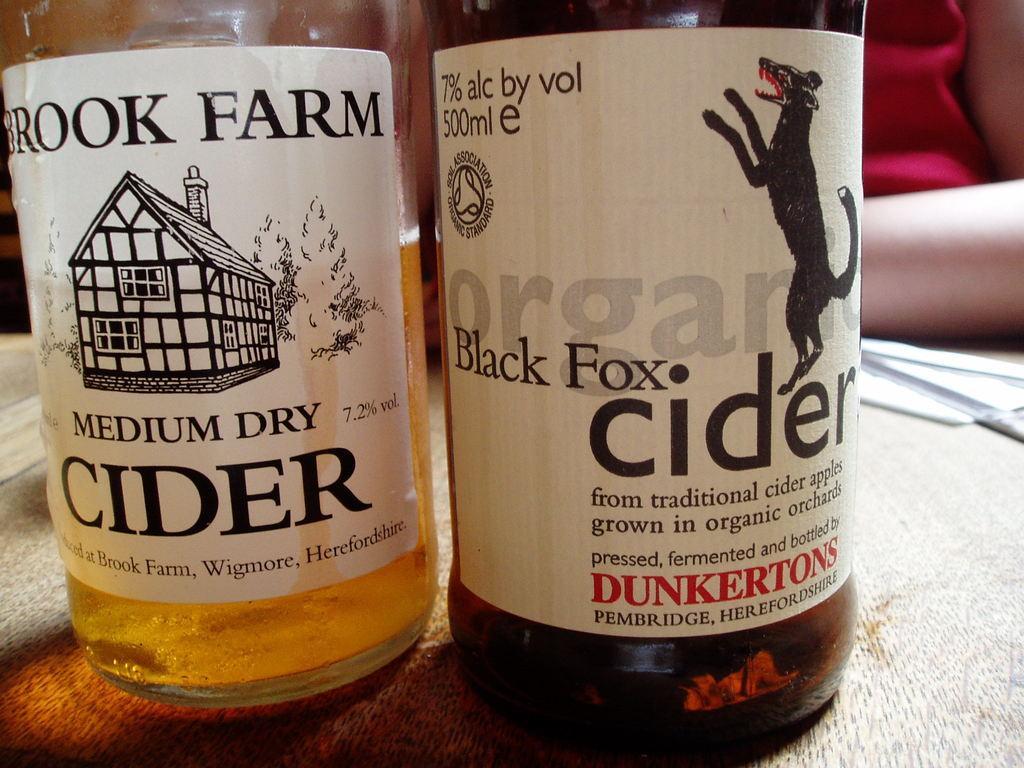How would you summarize this image in a sentence or two? I can see two bottles on a table and at the background i can see a person. 